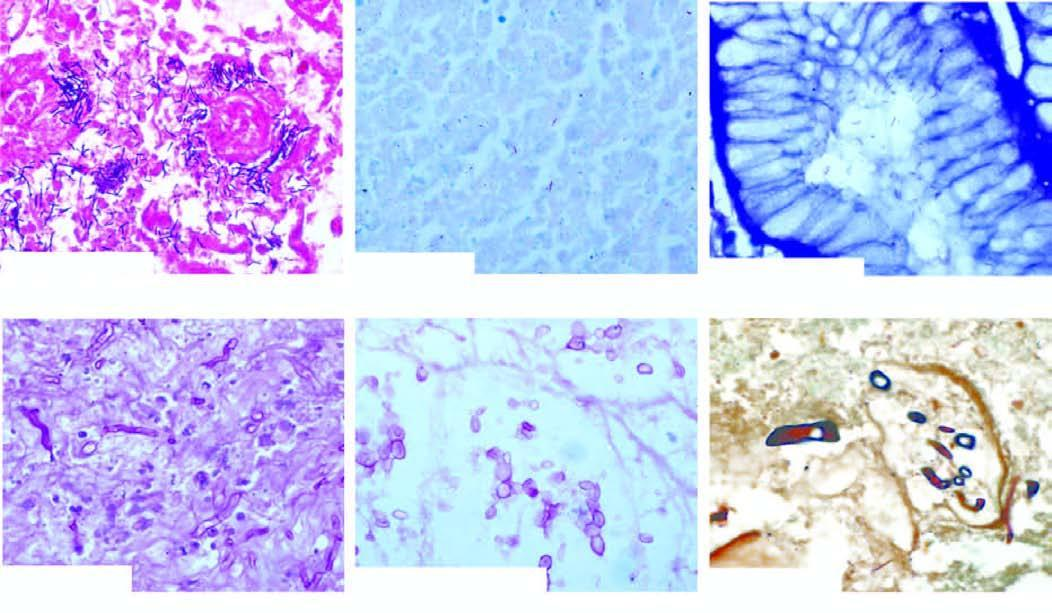what is ommon stains used for?
Answer the question using a single word or phrase. Demonstration of microbes 